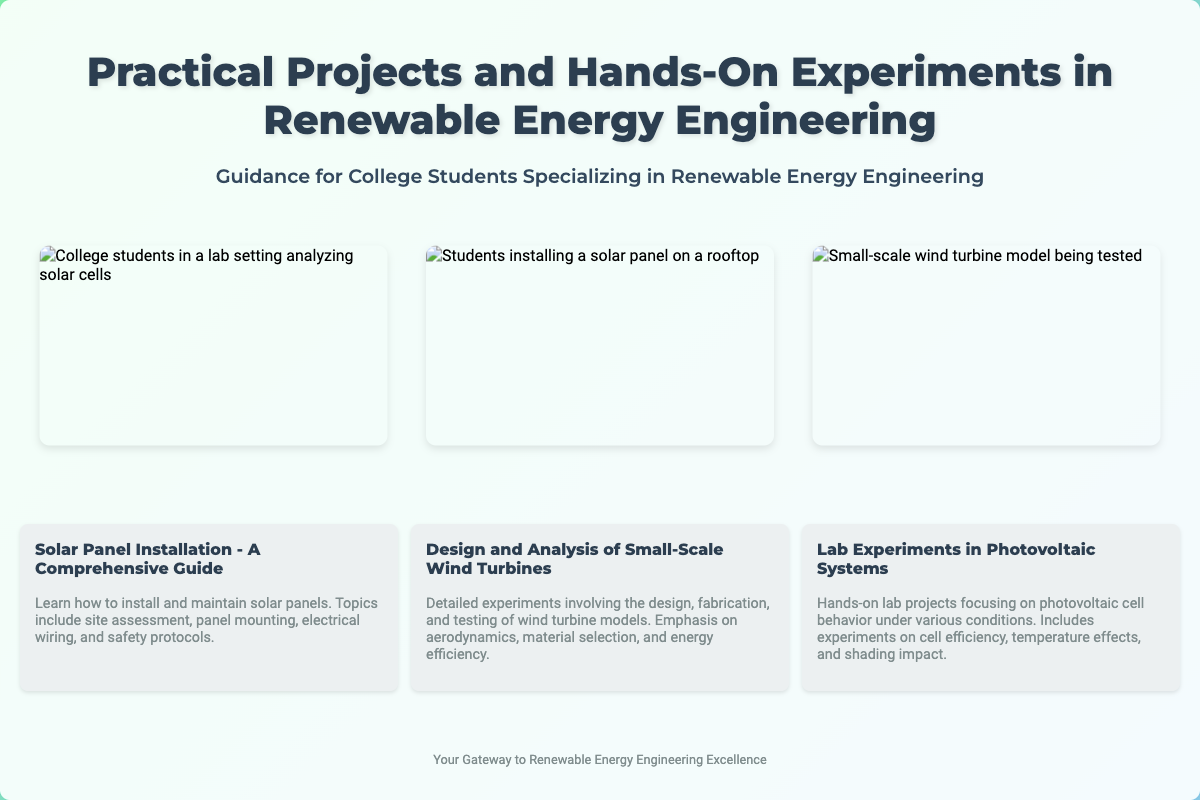What is the title of the book? The title of the book is prominently displayed at the top of the cover.
Answer: Practical Projects and Hands-On Experiments in Renewable Energy Engineering What is the subtitle of the book? The subtitle provides additional context about the target audience and focus of the book.
Answer: Guidance for College Students Specializing in Renewable Energy Engineering What is one of the topics covered related to solar panels? The document lists a specific project related to solar panels which includes essential topics.
Answer: Solar Panel Installation - A Comprehensive Guide How many images are included in the collage? The collage features three distinct images relevant to the content of the book.
Answer: Three What is one focus area in wind turbine experiments? The document indicates an aspect of wind turbine models that will be explored in detail.
Answer: Design and Analysis of Small-Scale Wind Turbines What is the primary purpose of the book? The overall aim of the book is outlined in the footer, indicating its benefit to the reader.
Answer: Your Gateway to Renewable Energy Engineering Excellence What type of educational setting is depicted in the images? The images portray a specific environment where students engage with renewable energy engineering projects.
Answer: Lab settings What is emphasized in the lab experiments section? The snapshot item describes the focus of lab experiments related to photovoltaic systems.
Answer: Photovoltaic cell behavior What are the students doing in the second image? The image provides a visual representation of a specific activity involving students and renewable energy.
Answer: Installing a solar panel on a rooftop 